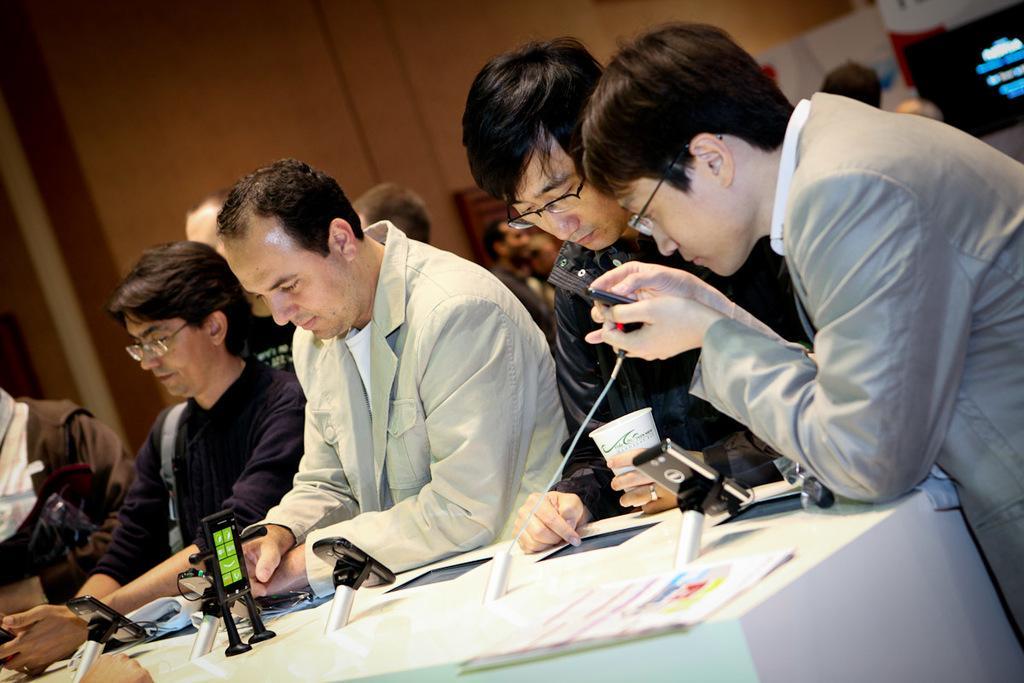Could you give a brief overview of what you see in this image? In the picture I can see some people are standing in front of the table, on which we can see some objects along with some papers. 